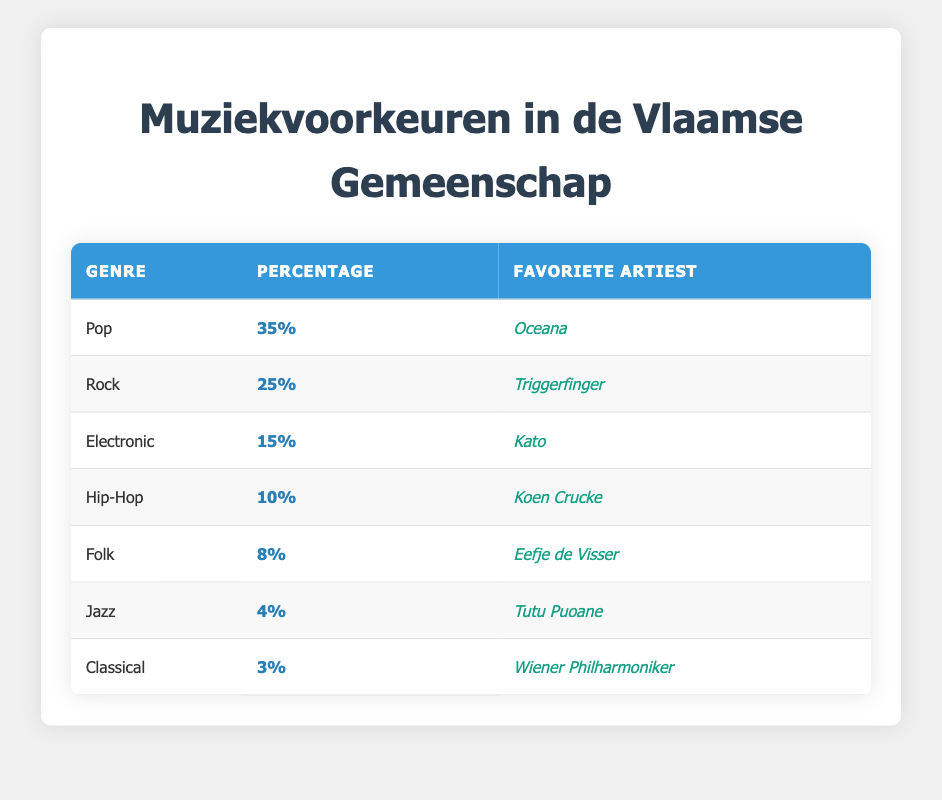What is the most popular music genre in the Flemish community? By looking at the percentage values in the table, "Pop" holds the highest percentage at 35%, which indicates it is the most popular music genre among the respondents.
Answer: Pop Which artist is favored by those who prefer Rock music? The table shows that the favorite artist for the Rock genre is "Triggerfinger."
Answer: Triggerfinger What percentage of the survey respondents prefer Jazz music? The table clearly states that 4% of respondents indicated a preference for Jazz music.
Answer: 4% How many genres have a percentage of 10% or higher? Looking at the percentage values, we see Pop (35%), Rock (25%), Electronic (15%), and Hip-Hop (10%). This adds up to 4 genres.
Answer: 4 What is the difference in percentage between Pop and Classical music preferences? The difference is calculated by subtracting the percentage of Classical (3%) from Pop (35%): 35% - 3% = 32%.
Answer: 32% Is Eefje de Visser the favorite artist for a genre that has 8% preference? The table indicates that "Eefje de Visser" is indeed associated with the Folk genre, which has an 8% preference. Therefore, the answer is yes.
Answer: Yes If you combine the percentages of Folk, Jazz, and Classical, what total percentage do you get? Adding the percentages: Folk (8%) + Jazz (4%) + Classical (3%) results in a total of 15%.
Answer: 15 What percentage of respondents prefer genres other than Pop and Rock combined? The percentages for Pop and Rock are 35% and 25%, respectively. Adding these gives 60%. To find the remaining percentages, we subtract from 100%: 100% - 60% = 40%.
Answer: 40 Which genre has the second-highest preference and what is its favorite artist? The genre with the second-highest preference after Pop is Rock at 25%, with "Triggerfinger" as its favorite artist.
Answer: Rock, Triggerfinger If the survey were to include another genre with an equal share to Jazz, how many total genres would have preference percentages next to each other? Jazz has 4%, and if another genre were added with an equal share, we would have 4 genres (Pop, Rock, Electronic, Hip-Hop, Folk, Jazz, and the new genre) - totaling to 8 genres.
Answer: 8 